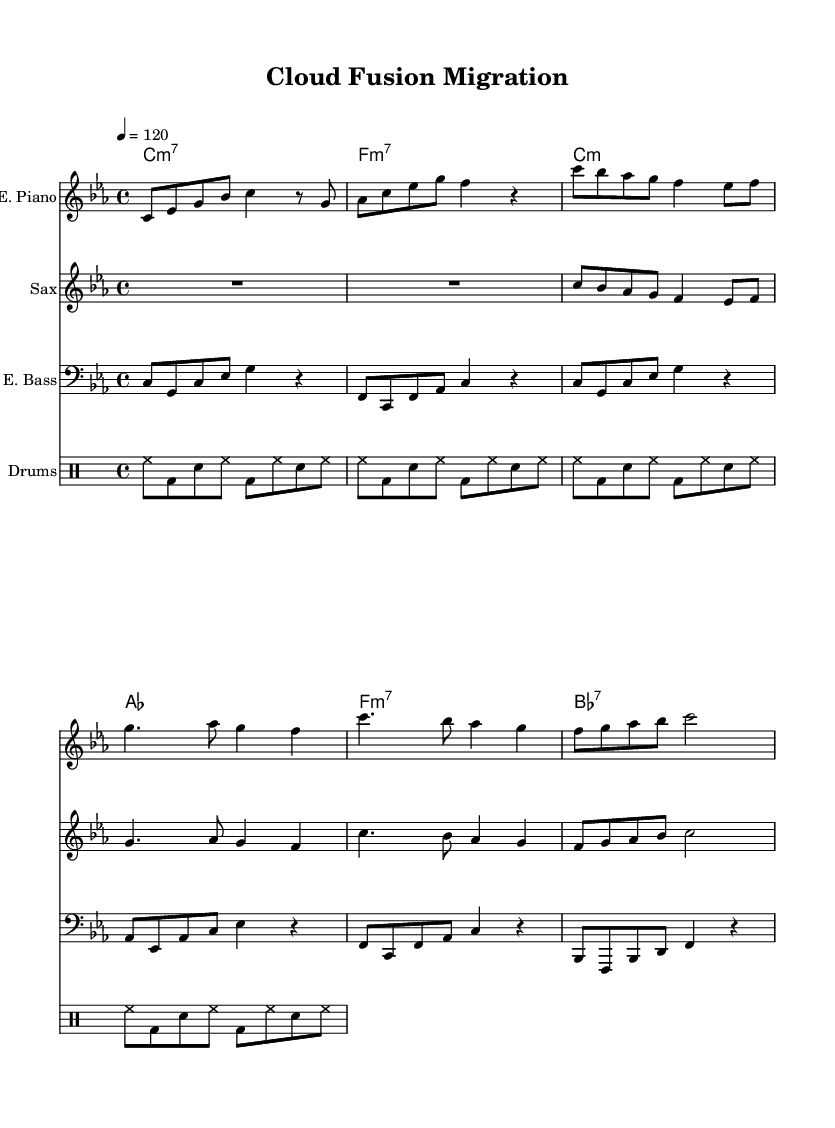What is the key signature of this music? The key signature is C minor, indicated by three flats in the key signature on the left side of the staff.
Answer: C minor What is the time signature of this piece? The time signature is 4/4, which can be found at the beginning of the score and indicates that there are four beats in each measure.
Answer: 4/4 What is the tempo marking of the piece? The tempo marking is 120 beats per minute, shown as "4 = 120" which indicates the speed of the performance.
Answer: 120 How many measures are in the electric piano part? The electric piano part has a total of 8 measures, as indicated by the grouping of notes from the beginning to the end of the part.
Answer: 8 measures What chords are used in the piece? The chords listed include C minor 7, F minor 7, C minor, A flat, F minor 7, and B flat 7, indicating the harmonic structure throughout the piece.
Answer: C minor 7, F minor 7, C minor, A flat, F minor 7, B flat 7 Which instrument plays the melody primarily? The saxophone plays the melody primarily, as it appears in the treble clef staff and presents the most expressive melodic lines.
Answer: Saxophone What is the style of this musical piece? This piece is in the jazz fusion style, characterized by its blending of jazz elements with electronic instruments and complex rhythms, as reflected in the overall arrangement.
Answer: Jazz fusion 